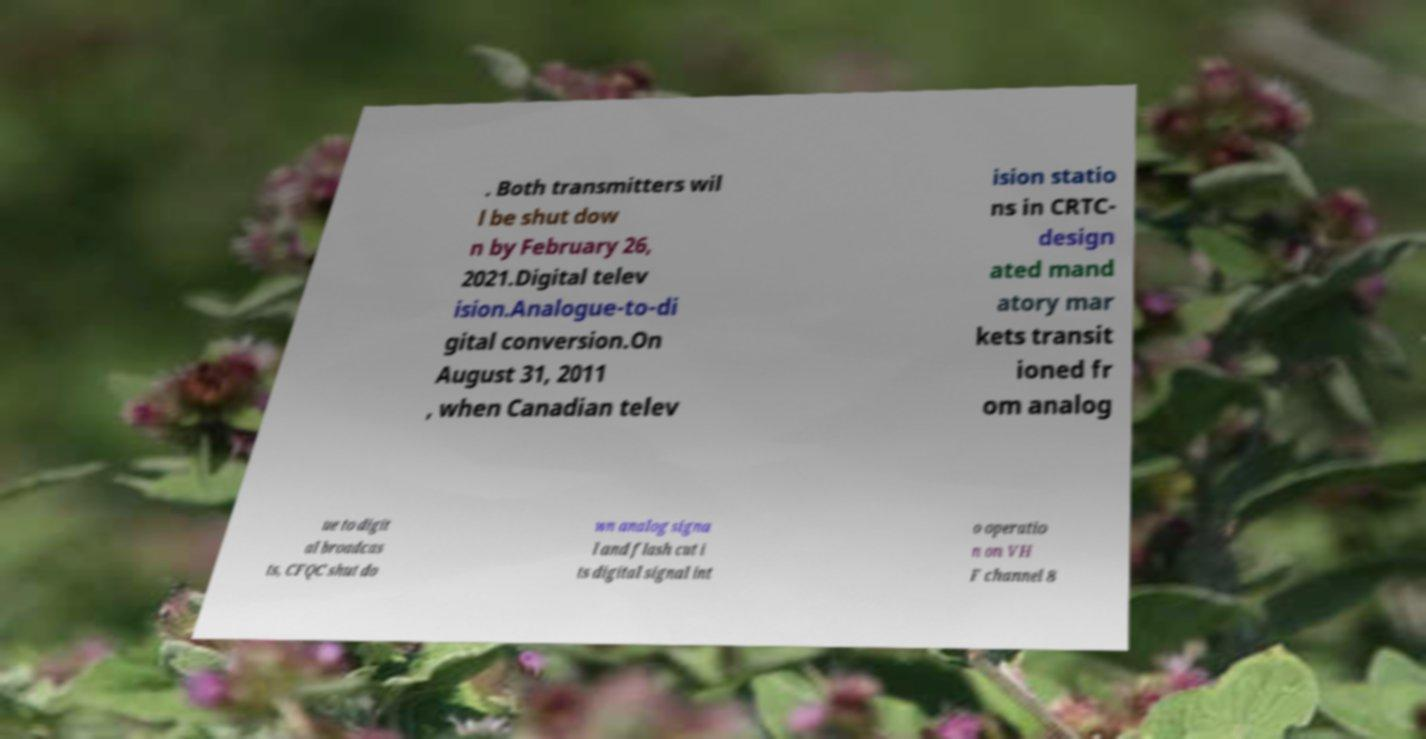Can you read and provide the text displayed in the image?This photo seems to have some interesting text. Can you extract and type it out for me? . Both transmitters wil l be shut dow n by February 26, 2021.Digital telev ision.Analogue-to-di gital conversion.On August 31, 2011 , when Canadian telev ision statio ns in CRTC- design ated mand atory mar kets transit ioned fr om analog ue to digit al broadcas ts, CFQC shut do wn analog signa l and flash cut i ts digital signal int o operatio n on VH F channel 8 